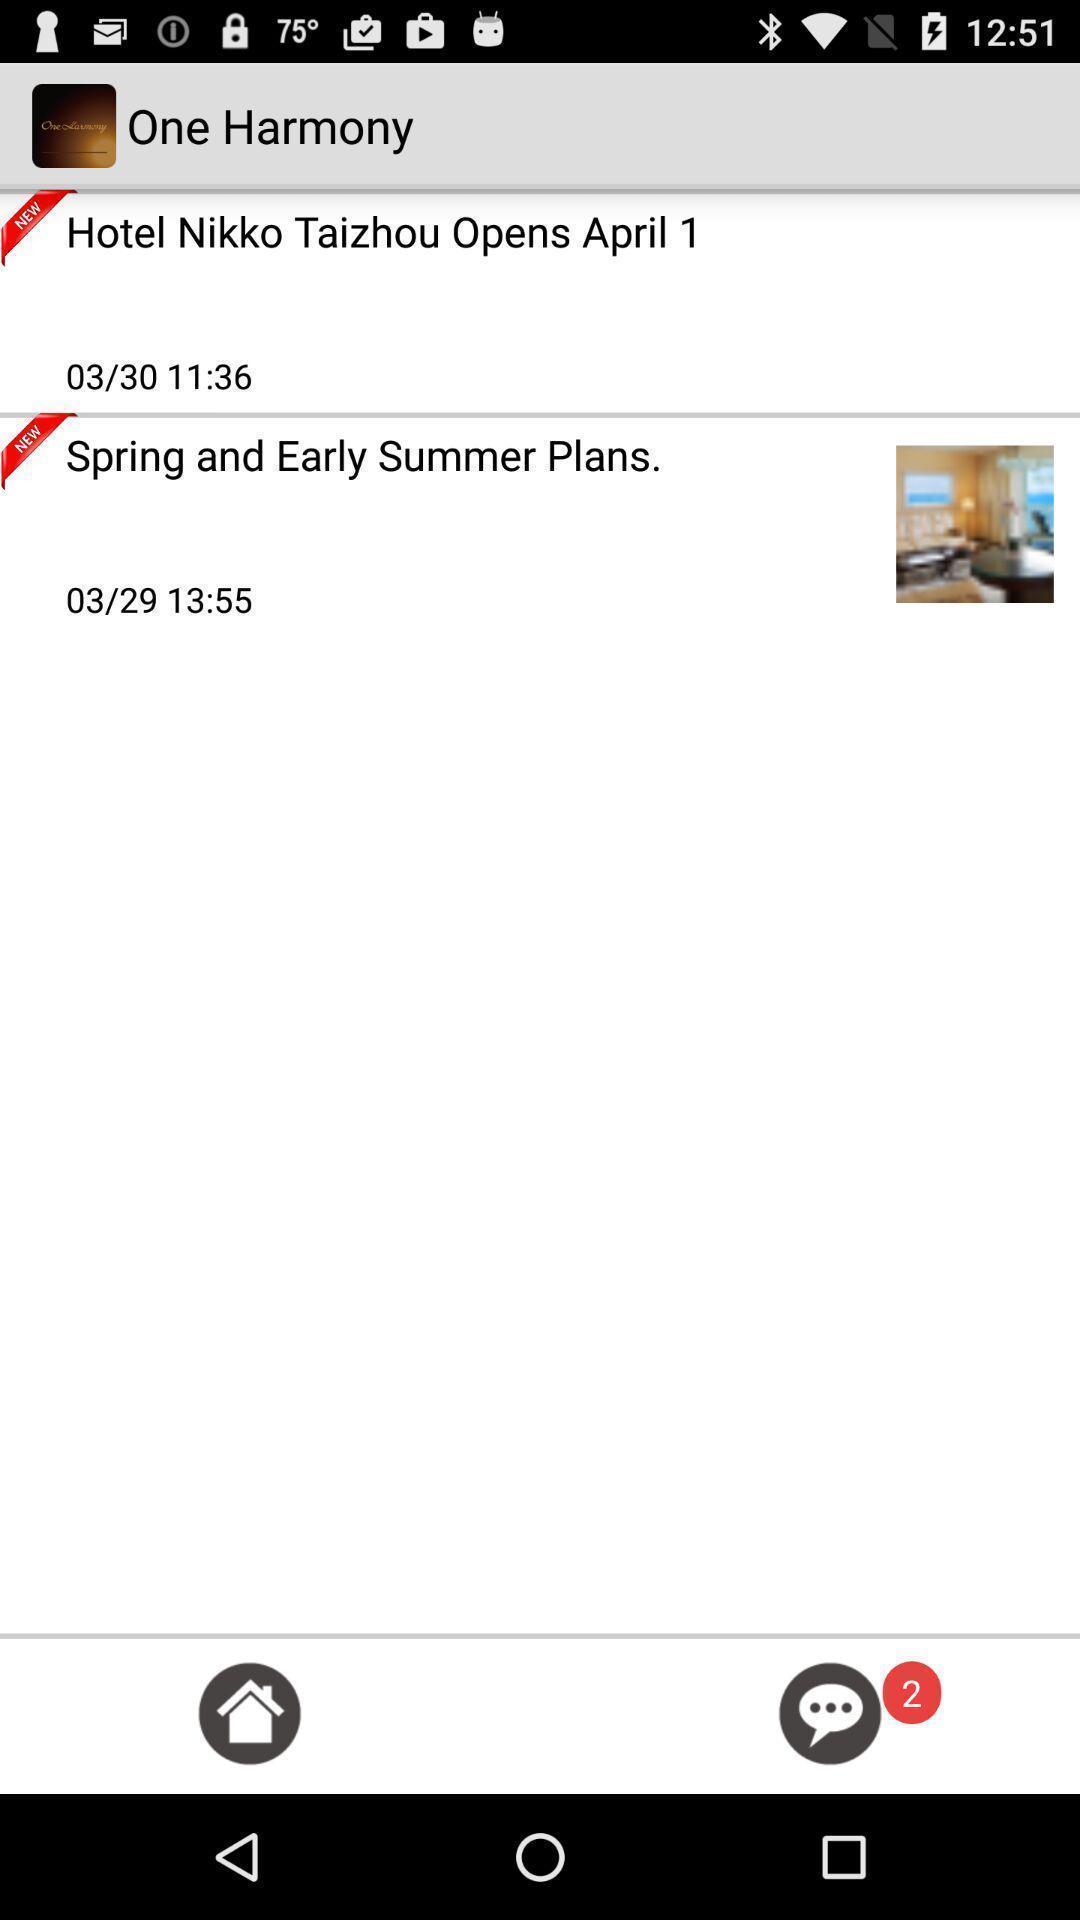Describe the key features of this screenshot. Screen showing hotel booking app. 